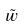<formula> <loc_0><loc_0><loc_500><loc_500>\tilde { w }</formula> 